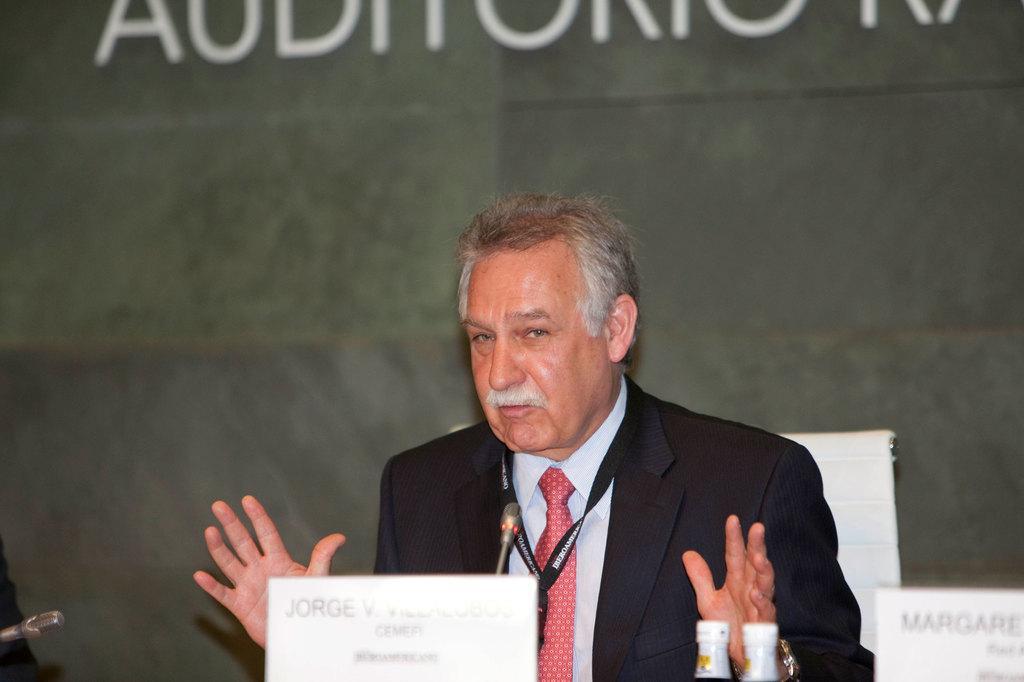How would you summarize this image in a sentence or two? This image consists of a man wearing a black suit. He is standing in front of a podium and talking in a mic. In the front, we can see two bottles and a name board. In the background, there is a wall. 